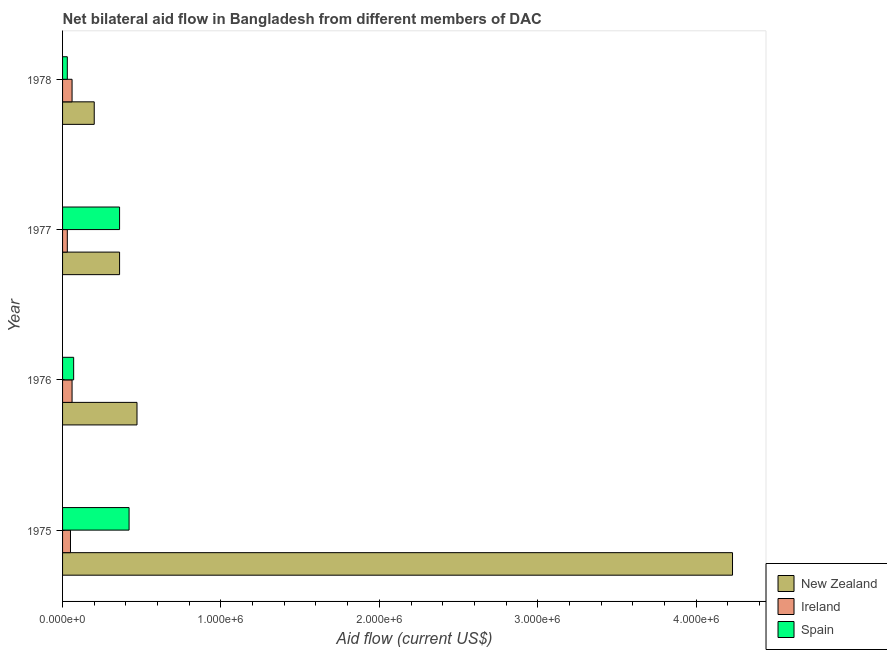Are the number of bars on each tick of the Y-axis equal?
Provide a short and direct response. Yes. How many bars are there on the 1st tick from the top?
Provide a succinct answer. 3. What is the label of the 3rd group of bars from the top?
Your answer should be very brief. 1976. What is the amount of aid provided by ireland in 1976?
Keep it short and to the point. 6.00e+04. Across all years, what is the maximum amount of aid provided by new zealand?
Ensure brevity in your answer.  4.23e+06. Across all years, what is the minimum amount of aid provided by ireland?
Make the answer very short. 3.00e+04. In which year was the amount of aid provided by spain maximum?
Your answer should be very brief. 1975. What is the total amount of aid provided by new zealand in the graph?
Your answer should be compact. 5.26e+06. What is the difference between the amount of aid provided by ireland in 1975 and that in 1976?
Your response must be concise. -10000. What is the difference between the amount of aid provided by ireland in 1978 and the amount of aid provided by new zealand in 1977?
Provide a short and direct response. -3.00e+05. What is the average amount of aid provided by ireland per year?
Your answer should be very brief. 5.00e+04. In the year 1978, what is the difference between the amount of aid provided by spain and amount of aid provided by ireland?
Your answer should be very brief. -3.00e+04. In how many years, is the amount of aid provided by ireland greater than 800000 US$?
Give a very brief answer. 0. Is the amount of aid provided by ireland in 1977 less than that in 1978?
Make the answer very short. Yes. What is the difference between the highest and the lowest amount of aid provided by new zealand?
Your answer should be compact. 4.03e+06. In how many years, is the amount of aid provided by ireland greater than the average amount of aid provided by ireland taken over all years?
Provide a succinct answer. 2. What does the 2nd bar from the bottom in 1976 represents?
Your answer should be compact. Ireland. Is it the case that in every year, the sum of the amount of aid provided by new zealand and amount of aid provided by ireland is greater than the amount of aid provided by spain?
Keep it short and to the point. Yes. Are all the bars in the graph horizontal?
Offer a very short reply. Yes. How many years are there in the graph?
Ensure brevity in your answer.  4. Are the values on the major ticks of X-axis written in scientific E-notation?
Offer a very short reply. Yes. How many legend labels are there?
Provide a short and direct response. 3. What is the title of the graph?
Offer a very short reply. Net bilateral aid flow in Bangladesh from different members of DAC. What is the label or title of the X-axis?
Provide a short and direct response. Aid flow (current US$). What is the Aid flow (current US$) in New Zealand in 1975?
Provide a short and direct response. 4.23e+06. What is the Aid flow (current US$) in Ireland in 1975?
Keep it short and to the point. 5.00e+04. What is the Aid flow (current US$) of Spain in 1975?
Make the answer very short. 4.20e+05. What is the Aid flow (current US$) of New Zealand in 1976?
Your answer should be compact. 4.70e+05. What is the Aid flow (current US$) in Ireland in 1976?
Make the answer very short. 6.00e+04. What is the Aid flow (current US$) of Ireland in 1977?
Offer a very short reply. 3.00e+04. What is the Aid flow (current US$) in Spain in 1977?
Offer a terse response. 3.60e+05. What is the Aid flow (current US$) of New Zealand in 1978?
Your answer should be very brief. 2.00e+05. What is the Aid flow (current US$) of Ireland in 1978?
Give a very brief answer. 6.00e+04. What is the Aid flow (current US$) of Spain in 1978?
Your response must be concise. 3.00e+04. Across all years, what is the maximum Aid flow (current US$) in New Zealand?
Your response must be concise. 4.23e+06. Across all years, what is the maximum Aid flow (current US$) in Ireland?
Offer a terse response. 6.00e+04. Across all years, what is the minimum Aid flow (current US$) in Spain?
Keep it short and to the point. 3.00e+04. What is the total Aid flow (current US$) in New Zealand in the graph?
Keep it short and to the point. 5.26e+06. What is the total Aid flow (current US$) of Ireland in the graph?
Your response must be concise. 2.00e+05. What is the total Aid flow (current US$) of Spain in the graph?
Your answer should be very brief. 8.80e+05. What is the difference between the Aid flow (current US$) in New Zealand in 1975 and that in 1976?
Provide a short and direct response. 3.76e+06. What is the difference between the Aid flow (current US$) in Ireland in 1975 and that in 1976?
Your answer should be very brief. -10000. What is the difference between the Aid flow (current US$) in New Zealand in 1975 and that in 1977?
Offer a terse response. 3.87e+06. What is the difference between the Aid flow (current US$) in Ireland in 1975 and that in 1977?
Give a very brief answer. 2.00e+04. What is the difference between the Aid flow (current US$) of Spain in 1975 and that in 1977?
Provide a succinct answer. 6.00e+04. What is the difference between the Aid flow (current US$) of New Zealand in 1975 and that in 1978?
Offer a very short reply. 4.03e+06. What is the difference between the Aid flow (current US$) in Ireland in 1975 and that in 1978?
Your answer should be very brief. -10000. What is the difference between the Aid flow (current US$) in Spain in 1976 and that in 1977?
Provide a succinct answer. -2.90e+05. What is the difference between the Aid flow (current US$) of New Zealand in 1976 and that in 1978?
Ensure brevity in your answer.  2.70e+05. What is the difference between the Aid flow (current US$) in Spain in 1977 and that in 1978?
Give a very brief answer. 3.30e+05. What is the difference between the Aid flow (current US$) of New Zealand in 1975 and the Aid flow (current US$) of Ireland in 1976?
Offer a very short reply. 4.17e+06. What is the difference between the Aid flow (current US$) of New Zealand in 1975 and the Aid flow (current US$) of Spain in 1976?
Ensure brevity in your answer.  4.16e+06. What is the difference between the Aid flow (current US$) of New Zealand in 1975 and the Aid flow (current US$) of Ireland in 1977?
Give a very brief answer. 4.20e+06. What is the difference between the Aid flow (current US$) in New Zealand in 1975 and the Aid flow (current US$) in Spain in 1977?
Provide a succinct answer. 3.87e+06. What is the difference between the Aid flow (current US$) of Ireland in 1975 and the Aid flow (current US$) of Spain in 1977?
Offer a very short reply. -3.10e+05. What is the difference between the Aid flow (current US$) in New Zealand in 1975 and the Aid flow (current US$) in Ireland in 1978?
Provide a succinct answer. 4.17e+06. What is the difference between the Aid flow (current US$) in New Zealand in 1975 and the Aid flow (current US$) in Spain in 1978?
Provide a succinct answer. 4.20e+06. What is the difference between the Aid flow (current US$) in New Zealand in 1976 and the Aid flow (current US$) in Spain in 1977?
Provide a short and direct response. 1.10e+05. What is the difference between the Aid flow (current US$) in Ireland in 1976 and the Aid flow (current US$) in Spain in 1977?
Offer a very short reply. -3.00e+05. What is the difference between the Aid flow (current US$) of New Zealand in 1976 and the Aid flow (current US$) of Spain in 1978?
Ensure brevity in your answer.  4.40e+05. What is the difference between the Aid flow (current US$) in Ireland in 1976 and the Aid flow (current US$) in Spain in 1978?
Make the answer very short. 3.00e+04. What is the difference between the Aid flow (current US$) of Ireland in 1977 and the Aid flow (current US$) of Spain in 1978?
Give a very brief answer. 0. What is the average Aid flow (current US$) of New Zealand per year?
Your answer should be compact. 1.32e+06. What is the average Aid flow (current US$) of Spain per year?
Offer a terse response. 2.20e+05. In the year 1975, what is the difference between the Aid flow (current US$) in New Zealand and Aid flow (current US$) in Ireland?
Ensure brevity in your answer.  4.18e+06. In the year 1975, what is the difference between the Aid flow (current US$) in New Zealand and Aid flow (current US$) in Spain?
Ensure brevity in your answer.  3.81e+06. In the year 1975, what is the difference between the Aid flow (current US$) of Ireland and Aid flow (current US$) of Spain?
Offer a terse response. -3.70e+05. In the year 1976, what is the difference between the Aid flow (current US$) of New Zealand and Aid flow (current US$) of Ireland?
Offer a terse response. 4.10e+05. In the year 1976, what is the difference between the Aid flow (current US$) of Ireland and Aid flow (current US$) of Spain?
Your response must be concise. -10000. In the year 1977, what is the difference between the Aid flow (current US$) of New Zealand and Aid flow (current US$) of Ireland?
Ensure brevity in your answer.  3.30e+05. In the year 1977, what is the difference between the Aid flow (current US$) in New Zealand and Aid flow (current US$) in Spain?
Ensure brevity in your answer.  0. In the year 1977, what is the difference between the Aid flow (current US$) of Ireland and Aid flow (current US$) of Spain?
Offer a very short reply. -3.30e+05. In the year 1978, what is the difference between the Aid flow (current US$) of New Zealand and Aid flow (current US$) of Ireland?
Your answer should be compact. 1.40e+05. In the year 1978, what is the difference between the Aid flow (current US$) of New Zealand and Aid flow (current US$) of Spain?
Keep it short and to the point. 1.70e+05. In the year 1978, what is the difference between the Aid flow (current US$) of Ireland and Aid flow (current US$) of Spain?
Provide a short and direct response. 3.00e+04. What is the ratio of the Aid flow (current US$) of New Zealand in 1975 to that in 1976?
Make the answer very short. 9. What is the ratio of the Aid flow (current US$) in Ireland in 1975 to that in 1976?
Your answer should be compact. 0.83. What is the ratio of the Aid flow (current US$) in New Zealand in 1975 to that in 1977?
Provide a succinct answer. 11.75. What is the ratio of the Aid flow (current US$) of Ireland in 1975 to that in 1977?
Offer a terse response. 1.67. What is the ratio of the Aid flow (current US$) in New Zealand in 1975 to that in 1978?
Provide a succinct answer. 21.15. What is the ratio of the Aid flow (current US$) of Ireland in 1975 to that in 1978?
Your answer should be very brief. 0.83. What is the ratio of the Aid flow (current US$) in Spain in 1975 to that in 1978?
Keep it short and to the point. 14. What is the ratio of the Aid flow (current US$) in New Zealand in 1976 to that in 1977?
Your answer should be compact. 1.31. What is the ratio of the Aid flow (current US$) of Spain in 1976 to that in 1977?
Offer a terse response. 0.19. What is the ratio of the Aid flow (current US$) of New Zealand in 1976 to that in 1978?
Ensure brevity in your answer.  2.35. What is the ratio of the Aid flow (current US$) in Spain in 1976 to that in 1978?
Keep it short and to the point. 2.33. What is the ratio of the Aid flow (current US$) of Spain in 1977 to that in 1978?
Provide a succinct answer. 12. What is the difference between the highest and the second highest Aid flow (current US$) in New Zealand?
Your response must be concise. 3.76e+06. What is the difference between the highest and the second highest Aid flow (current US$) in Spain?
Offer a very short reply. 6.00e+04. What is the difference between the highest and the lowest Aid flow (current US$) in New Zealand?
Offer a terse response. 4.03e+06. What is the difference between the highest and the lowest Aid flow (current US$) in Ireland?
Make the answer very short. 3.00e+04. 